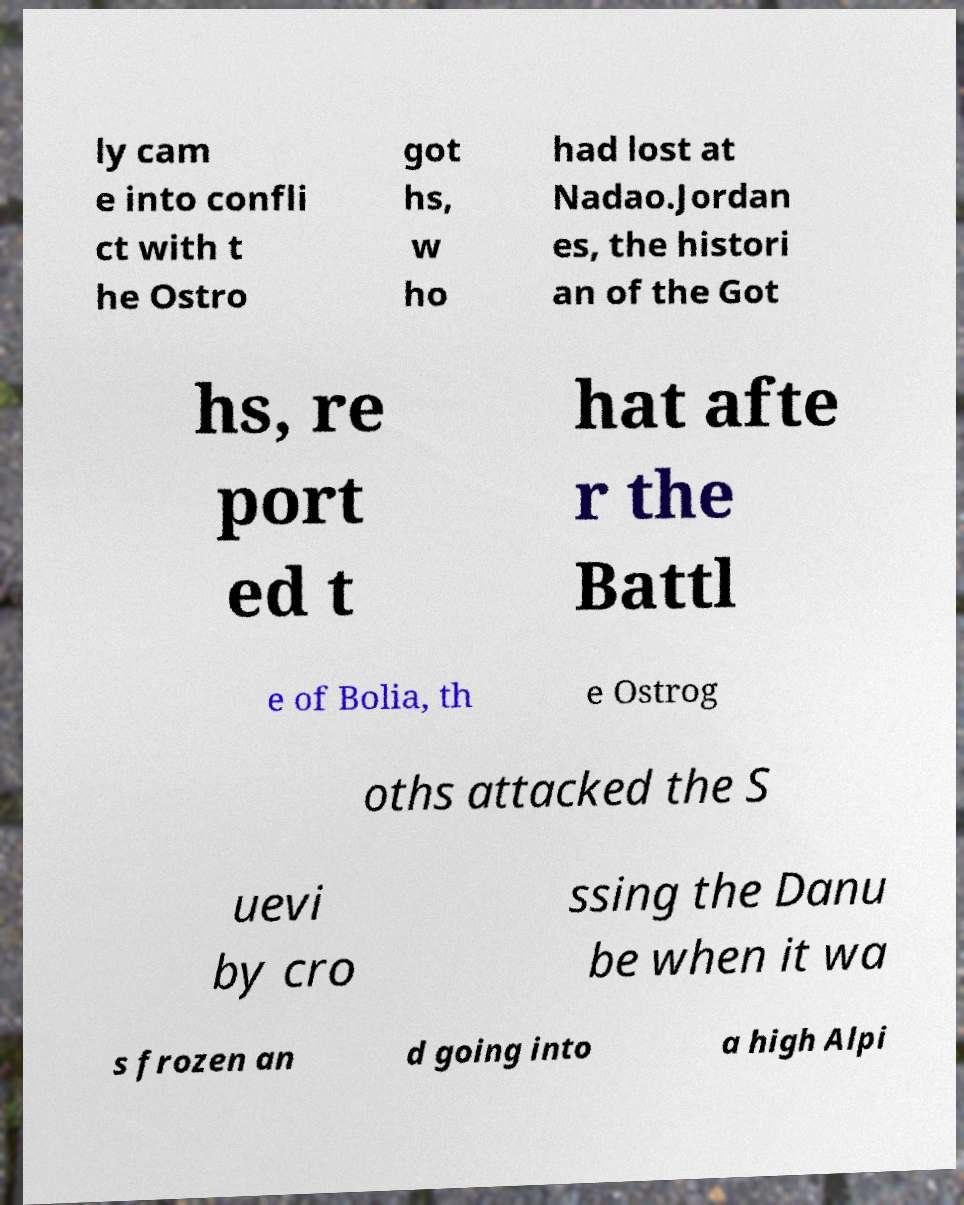I need the written content from this picture converted into text. Can you do that? ly cam e into confli ct with t he Ostro got hs, w ho had lost at Nadao.Jordan es, the histori an of the Got hs, re port ed t hat afte r the Battl e of Bolia, th e Ostrog oths attacked the S uevi by cro ssing the Danu be when it wa s frozen an d going into a high Alpi 